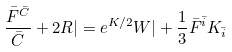<formula> <loc_0><loc_0><loc_500><loc_500>\frac { \bar { F } ^ { \bar { C } } } { \bar { C } } + 2 R | = e ^ { K / 2 } W | + \frac { 1 } { 3 } \bar { F } ^ { \bar { i } } K _ { \bar { i } }</formula> 